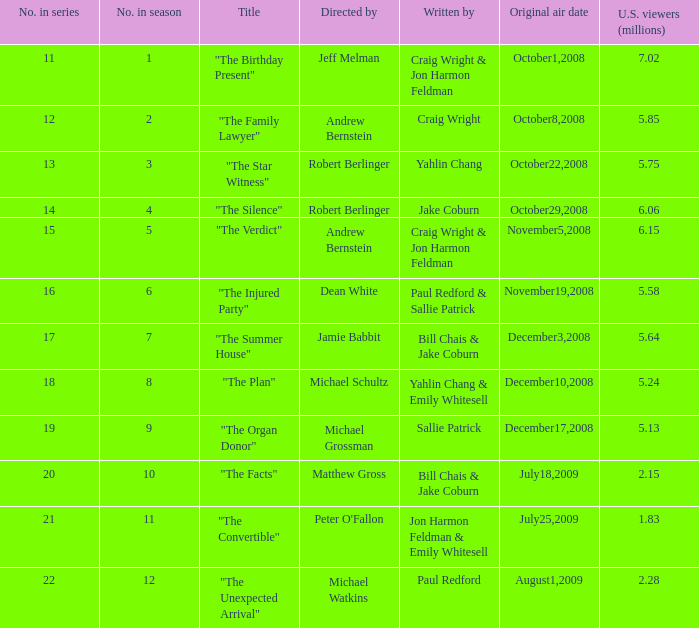What is the original air date of the episode directed by Jeff Melman? October1,2008. Help me parse the entirety of this table. {'header': ['No. in series', 'No. in season', 'Title', 'Directed by', 'Written by', 'Original air date', 'U.S. viewers (millions)'], 'rows': [['11', '1', '"The Birthday Present"', 'Jeff Melman', 'Craig Wright & Jon Harmon Feldman', 'October1,2008', '7.02'], ['12', '2', '"The Family Lawyer"', 'Andrew Bernstein', 'Craig Wright', 'October8,2008', '5.85'], ['13', '3', '"The Star Witness"', 'Robert Berlinger', 'Yahlin Chang', 'October22,2008', '5.75'], ['14', '4', '"The Silence"', 'Robert Berlinger', 'Jake Coburn', 'October29,2008', '6.06'], ['15', '5', '"The Verdict"', 'Andrew Bernstein', 'Craig Wright & Jon Harmon Feldman', 'November5,2008', '6.15'], ['16', '6', '"The Injured Party"', 'Dean White', 'Paul Redford & Sallie Patrick', 'November19,2008', '5.58'], ['17', '7', '"The Summer House"', 'Jamie Babbit', 'Bill Chais & Jake Coburn', 'December3,2008', '5.64'], ['18', '8', '"The Plan"', 'Michael Schultz', 'Yahlin Chang & Emily Whitesell', 'December10,2008', '5.24'], ['19', '9', '"The Organ Donor"', 'Michael Grossman', 'Sallie Patrick', 'December17,2008', '5.13'], ['20', '10', '"The Facts"', 'Matthew Gross', 'Bill Chais & Jake Coburn', 'July18,2009', '2.15'], ['21', '11', '"The Convertible"', "Peter O'Fallon", 'Jon Harmon Feldman & Emily Whitesell', 'July25,2009', '1.83'], ['22', '12', '"The Unexpected Arrival"', 'Michael Watkins', 'Paul Redford', 'August1,2009', '2.28']]} 